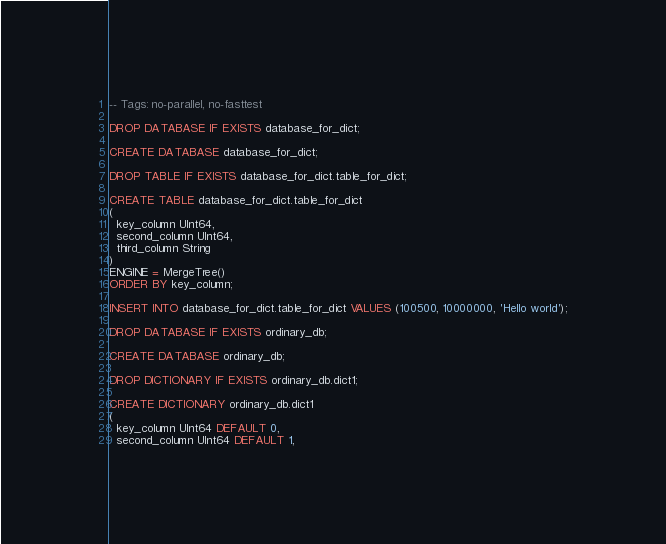Convert code to text. <code><loc_0><loc_0><loc_500><loc_500><_SQL_>-- Tags: no-parallel, no-fasttest

DROP DATABASE IF EXISTS database_for_dict;

CREATE DATABASE database_for_dict;

DROP TABLE IF EXISTS database_for_dict.table_for_dict;

CREATE TABLE database_for_dict.table_for_dict
(
  key_column UInt64,
  second_column UInt64,
  third_column String
)
ENGINE = MergeTree()
ORDER BY key_column;

INSERT INTO database_for_dict.table_for_dict VALUES (100500, 10000000, 'Hello world');

DROP DATABASE IF EXISTS ordinary_db;

CREATE DATABASE ordinary_db;

DROP DICTIONARY IF EXISTS ordinary_db.dict1;

CREATE DICTIONARY ordinary_db.dict1
(
  key_column UInt64 DEFAULT 0,
  second_column UInt64 DEFAULT 1,</code> 